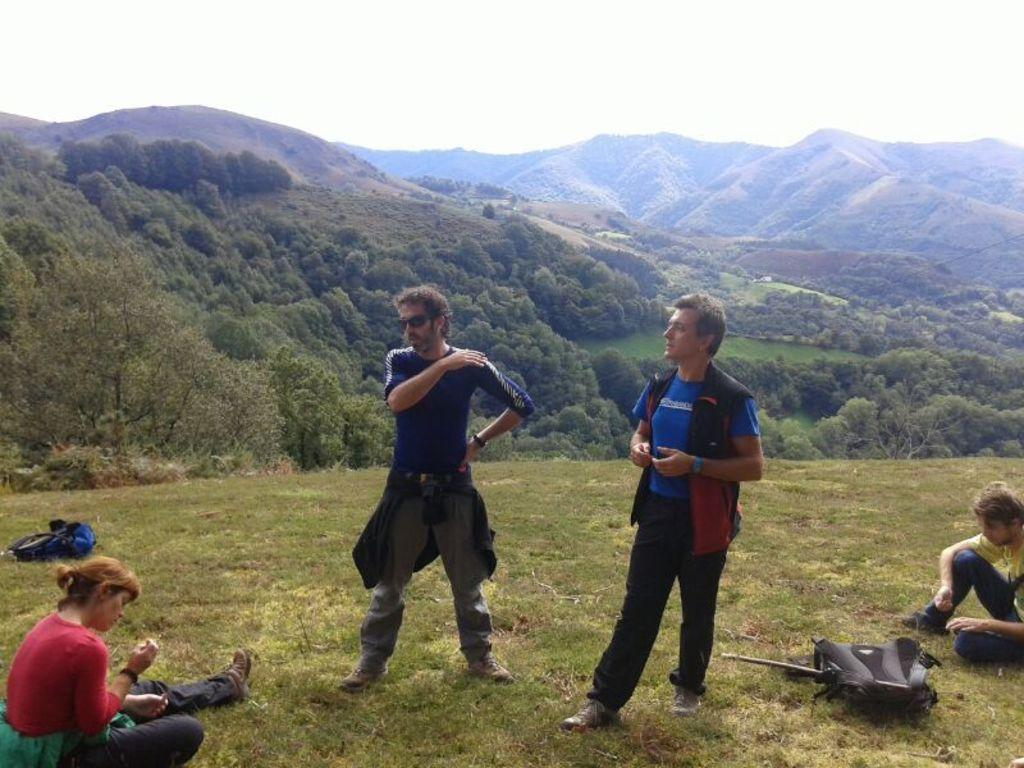What can be seen in the image that people might carry? There are bags in the image that people might carry. How many men are standing in the image? There are two men standing in the image. What are the two people on the grass doing? The two people on the grass are sitting. What else is visible in the image besides the people and bags? There are objects, trees, mountains, and the sky visible in the image. What type of linen is being used as bait in the image? There is no linen or bait present in the image. What kind of approval is being sought from the people in the image? There is no indication in the image that anyone is seeking approval from others. 